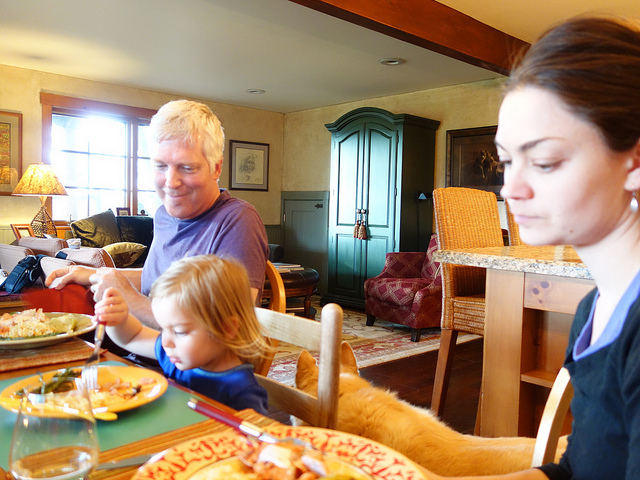Is there anything in the picture that suggests it is a special occasion? There are no clear signs of an event like a birthday or holiday celebration, such as decorations or gifts, visible in the image. The setting seems to be more indicative of a regular mealtime, with the focus being on the family gathering and interaction over the food. 